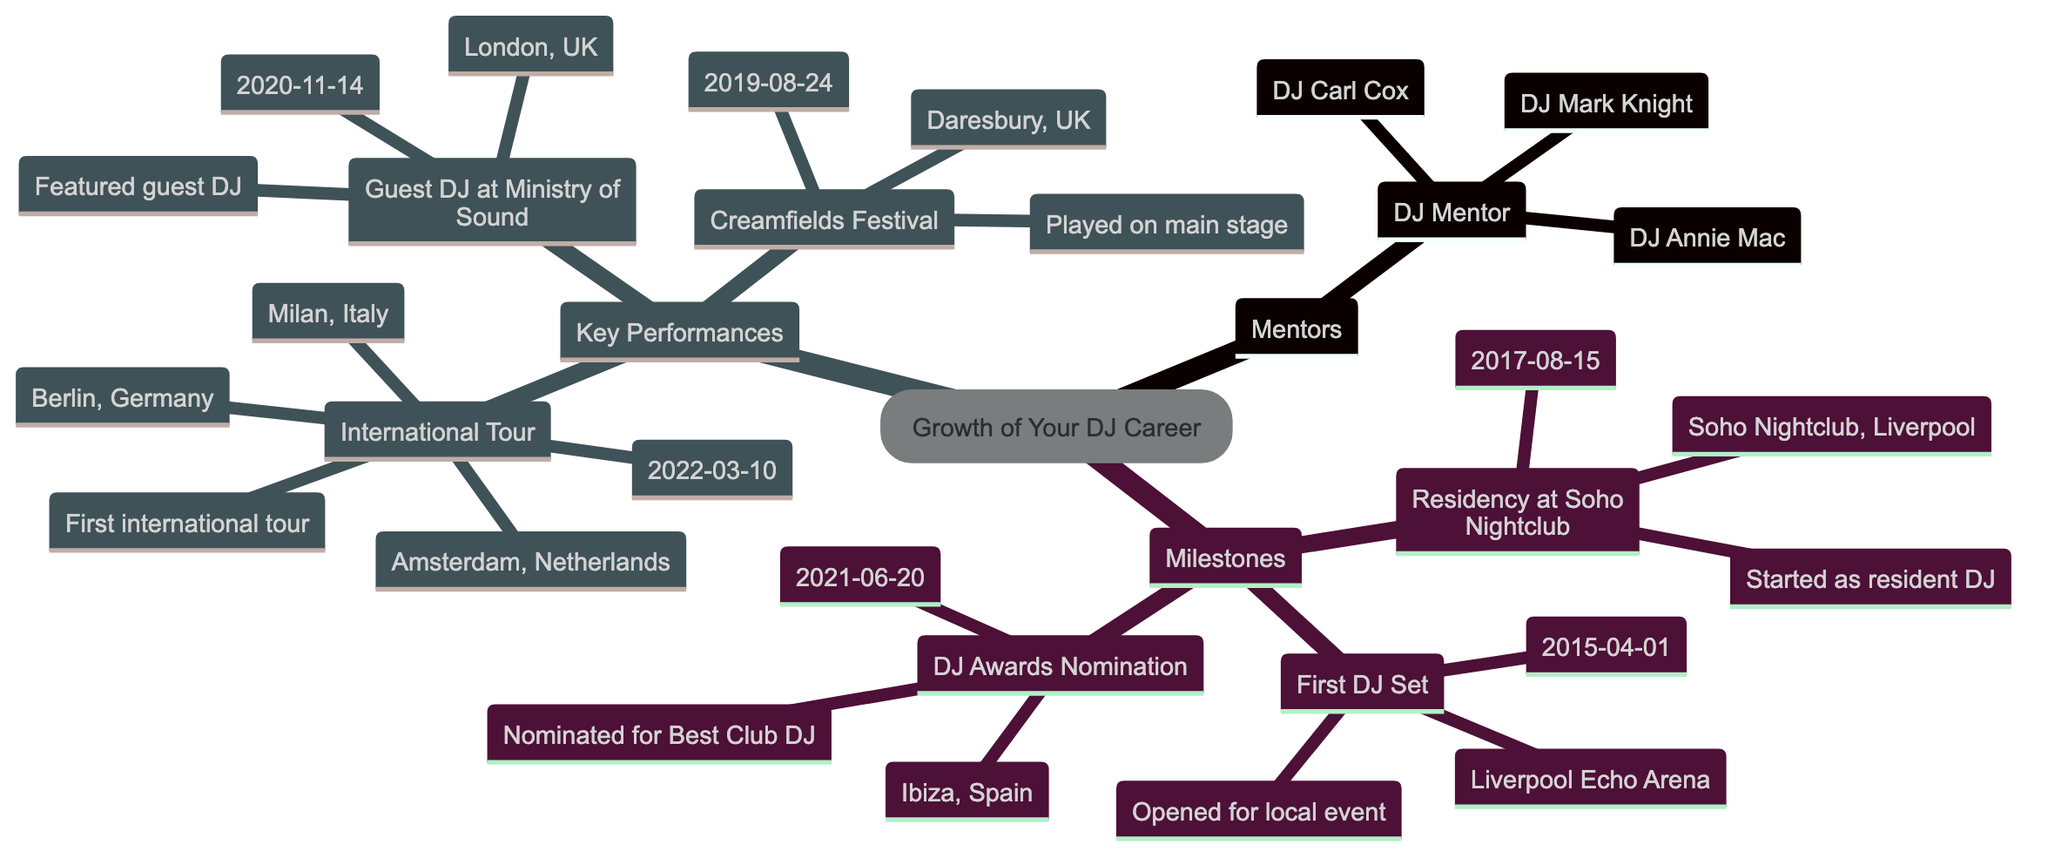What are the names of your mentors? The diagram lists three mentors under the "DJ Mentor" category: DJ Mark Knight, DJ Carl Cox, and DJ Annie Mac.
Answer: DJ Mark Knight, DJ Carl Cox, DJ Annie Mac When did you perform your first DJ set? The diagram indicates that the first DJ set took place on April 1, 2015, at the Liverpool Echo Arena.
Answer: 2015-04-01 Where did you have a residency? The residency is indicated as being at Soho Nightclub in Liverpool, which started on August 15, 2017.
Answer: Soho Nightclub, Liverpool How many key performances are listed? The diagram shows three key performances: Creamfields Festival, Guest DJ at Ministry of Sound, and International Tour.
Answer: 3 What is the date of your DJ Awards nomination? The diagram specifies that the DJ Awards nomination occurred on June 20, 2021, in Ibiza, Spain.
Answer: 2021-06-20 Which festival did you perform at on August 24, 2019? According to the diagram, the performance on that date was at Creamfields Festival in Daresbury, UK.
Answer: Creamfields Festival What were the locations of your International Tour? The diagram lists three locations for the International Tour: Milan, Italy; Berlin, Germany; and Amsterdam, Netherlands.
Answer: Milan, Italy; Berlin, Germany; Amsterdam, Netherlands What milestone marks the start of your DJ career? The diagram indicates that the first DJ set marks the beginning of the career, as it is the earliest listed milestone on April 1, 2015.
Answer: First DJ Set Which mentor is identified first in the diagram? The first mentor listed under the "DJ Mentor" category is DJ Mark Knight.
Answer: DJ Mark Knight 